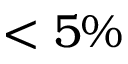<formula> <loc_0><loc_0><loc_500><loc_500>< 5 \%</formula> 